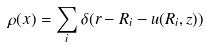<formula> <loc_0><loc_0><loc_500><loc_500>\rho ( x ) = \sum _ { i } \delta ( r - R _ { i } - u ( R _ { i } , z ) )</formula> 